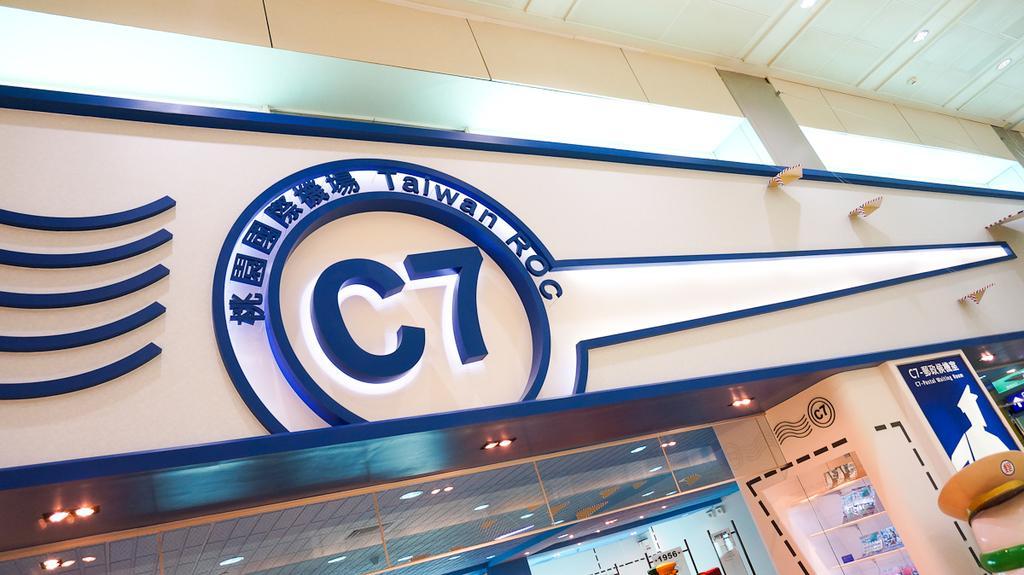In one or two sentences, can you explain what this image depicts? This is the inside picture of the building. 